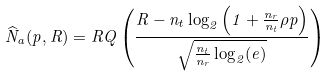Convert formula to latex. <formula><loc_0><loc_0><loc_500><loc_500>\widehat { N } _ { a } ( p , R ) = R Q \left ( \frac { R - n _ { t } \log _ { 2 } \left ( 1 + \frac { n _ { r } } { n _ { t } } \rho p \right ) } { \sqrt { \frac { n _ { t } } { n _ { r } } \log _ { 2 } ( e ) } } \right )</formula> 